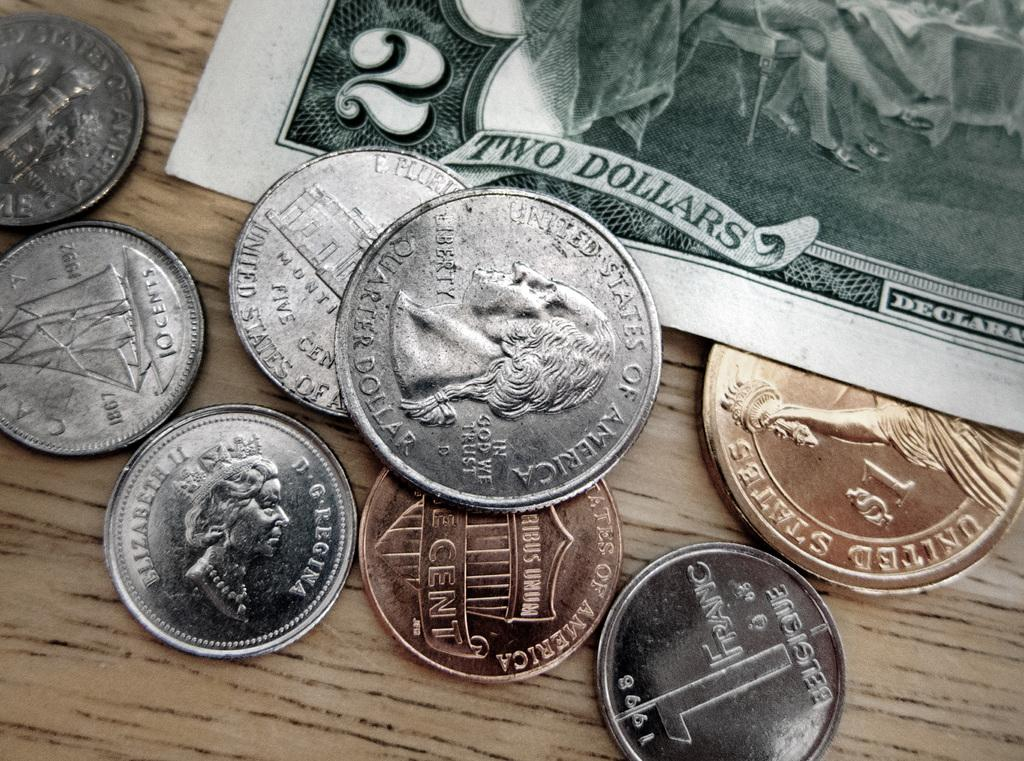<image>
Summarize the visual content of the image. a series of coins on top of a two dollar bill 